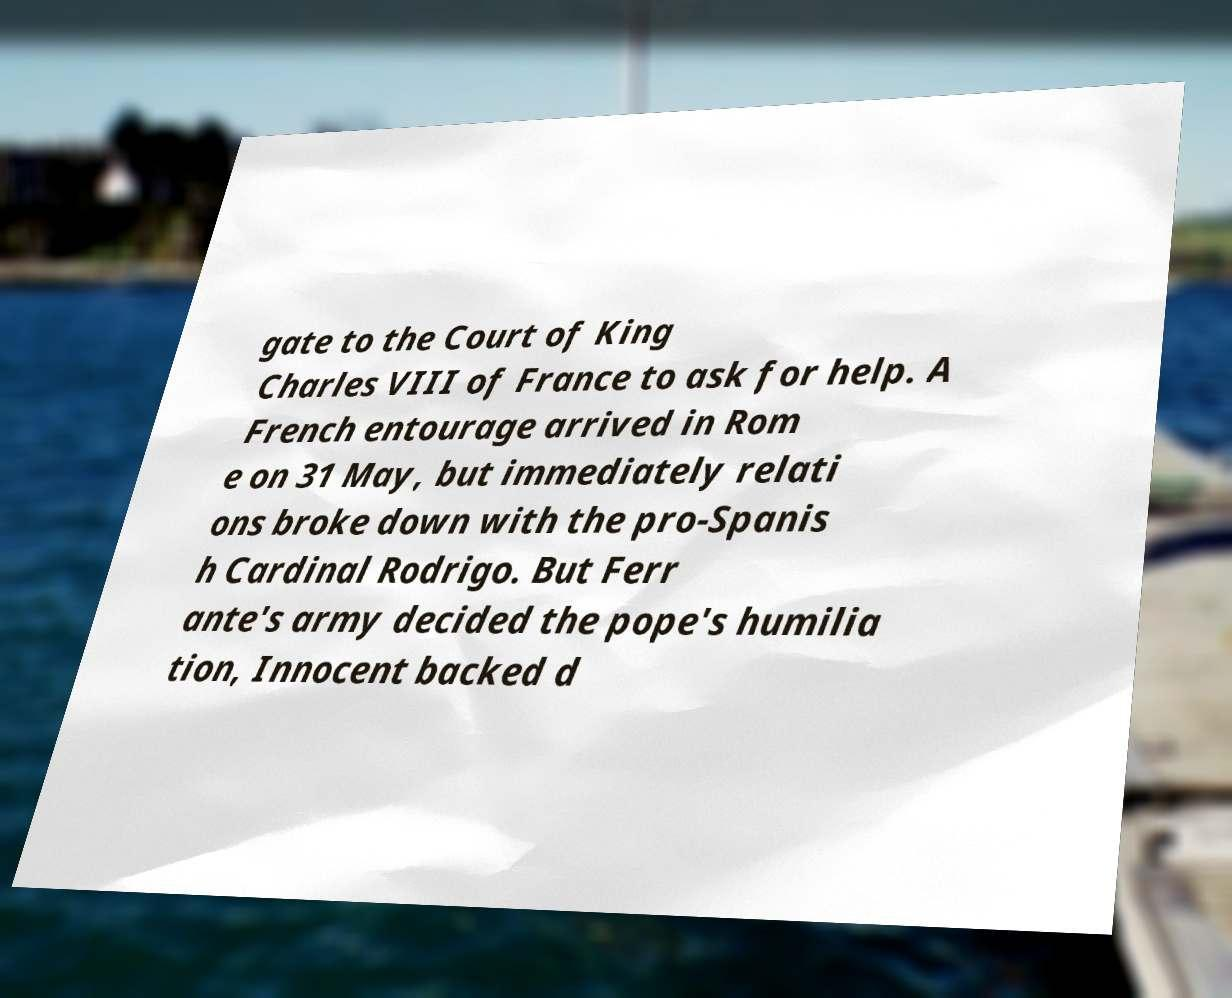Could you extract and type out the text from this image? gate to the Court of King Charles VIII of France to ask for help. A French entourage arrived in Rom e on 31 May, but immediately relati ons broke down with the pro-Spanis h Cardinal Rodrigo. But Ferr ante's army decided the pope's humilia tion, Innocent backed d 